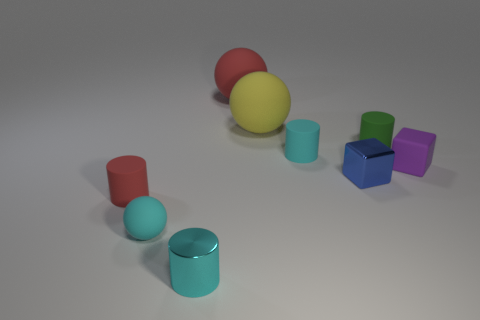Add 1 blue metal spheres. How many objects exist? 10 Subtract all cubes. How many objects are left? 7 Add 7 red rubber cylinders. How many red rubber cylinders exist? 8 Subtract 0 red cubes. How many objects are left? 9 Subtract all small rubber balls. Subtract all yellow objects. How many objects are left? 7 Add 6 large red matte balls. How many large red matte balls are left? 7 